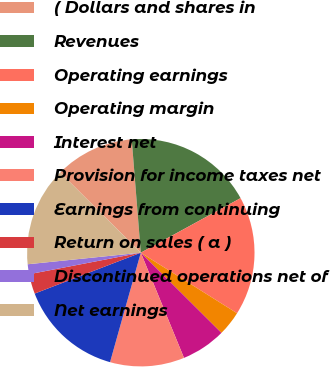Convert chart. <chart><loc_0><loc_0><loc_500><loc_500><pie_chart><fcel>( Dollars and shares in<fcel>Revenues<fcel>Operating earnings<fcel>Operating margin<fcel>Interest net<fcel>Provision for income taxes net<fcel>Earnings from continuing<fcel>Return on sales ( a )<fcel>Discontinued operations net of<fcel>Net earnings<nl><fcel>11.27%<fcel>18.31%<fcel>16.9%<fcel>3.52%<fcel>6.34%<fcel>10.56%<fcel>14.79%<fcel>2.82%<fcel>1.41%<fcel>14.08%<nl></chart> 